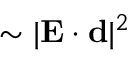<formula> <loc_0><loc_0><loc_500><loc_500>\sim | { E } \cdot { d } | ^ { 2 }</formula> 